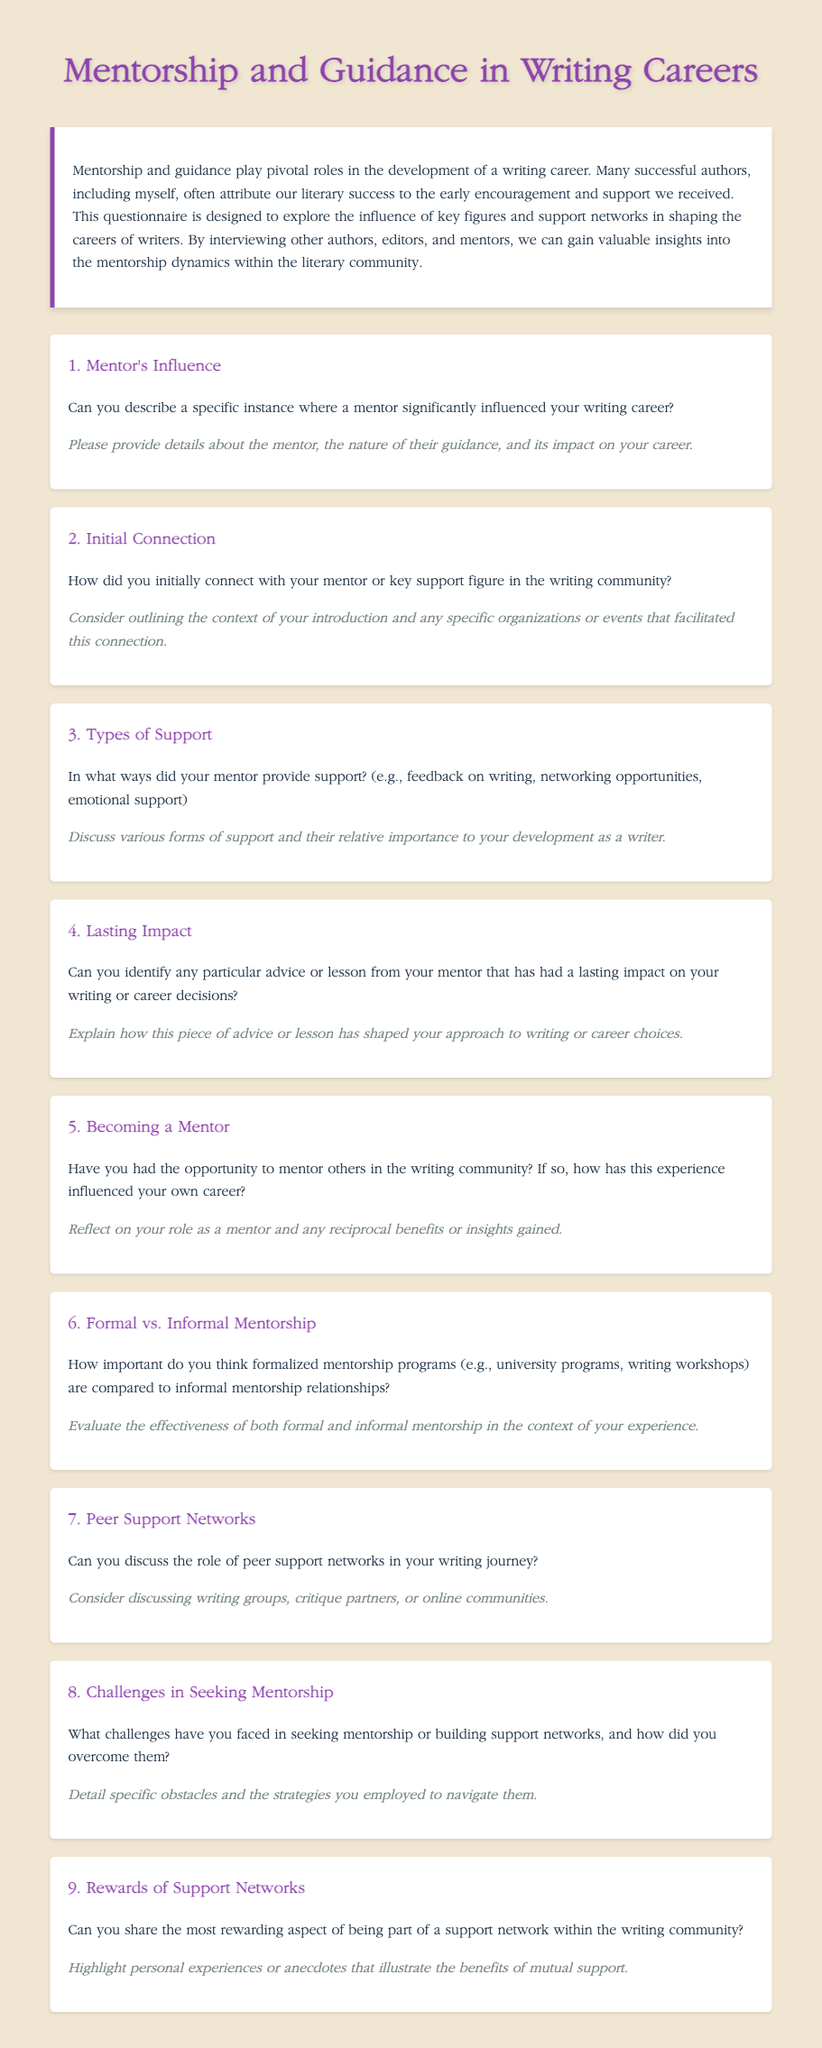What is the title of the document? The title of the document indicates the main theme it addresses, which is "Mentorship and Guidance in Writing Careers."
Answer: Mentorship and Guidance in Writing Careers How many main questions are in the questionnaire? The document contains a total of nine main questions that explore various aspects of mentorship and guidance in writing.
Answer: 9 What is the color of the document's background? The background color in the document is stated to be a light beige color, which is described as #f0e6d2 in the CSS.
Answer: #f0e6d2 What type of support is mentioned in the third question? The third question specifically asks about various forms of support provided by a mentor in the writing community.
Answer: feedback on writing, networking opportunities, emotional support Who are the targeted respondents of the questionnaire? The introduction highlights that the questionnaire aims to gather insights from successful authors, editors, and mentors in the writing community.
Answer: authors, editors, mentors Which section describes the introduction of the questionnaire? The introduction is detailed in a specific section that outlines its purpose and significance in relation to the mentorship dynamics within the literary community.
Answer: introduction What does the last question address? The ninth question discusses the rewarding aspects of being part of a support network, requesting personal experiences or anecdotes from respondents.
Answer: most rewarding aspect of being part of a support network What is the purpose of the questionnaire? The purpose of this questionnaire is to explore the influence of key figures and support networks in shaping the careers of writers.
Answer: explore the influence of key figures and support networks What color is used for the heading text? The heading text color used throughout the document is a shade of purple, specifically indicated as #8e44ad in the design.
Answer: #8e44ad 